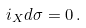Convert formula to latex. <formula><loc_0><loc_0><loc_500><loc_500>i _ { X } d \sigma = 0 \, .</formula> 